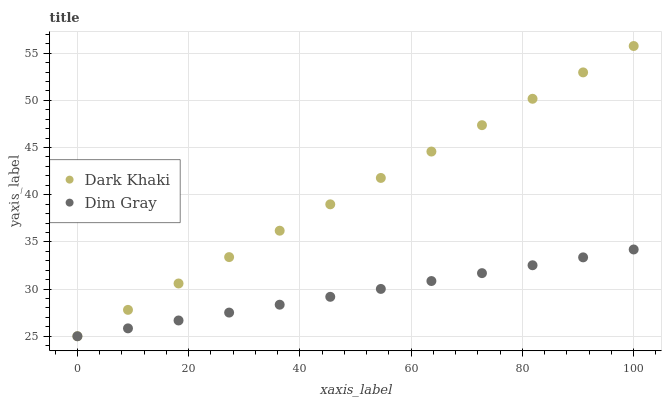Does Dim Gray have the minimum area under the curve?
Answer yes or no. Yes. Does Dark Khaki have the maximum area under the curve?
Answer yes or no. Yes. Does Dim Gray have the maximum area under the curve?
Answer yes or no. No. Is Dim Gray the smoothest?
Answer yes or no. Yes. Is Dark Khaki the roughest?
Answer yes or no. Yes. Is Dim Gray the roughest?
Answer yes or no. No. Does Dark Khaki have the lowest value?
Answer yes or no. Yes. Does Dark Khaki have the highest value?
Answer yes or no. Yes. Does Dim Gray have the highest value?
Answer yes or no. No. Does Dark Khaki intersect Dim Gray?
Answer yes or no. Yes. Is Dark Khaki less than Dim Gray?
Answer yes or no. No. Is Dark Khaki greater than Dim Gray?
Answer yes or no. No. 